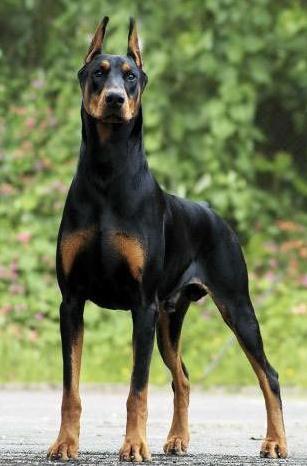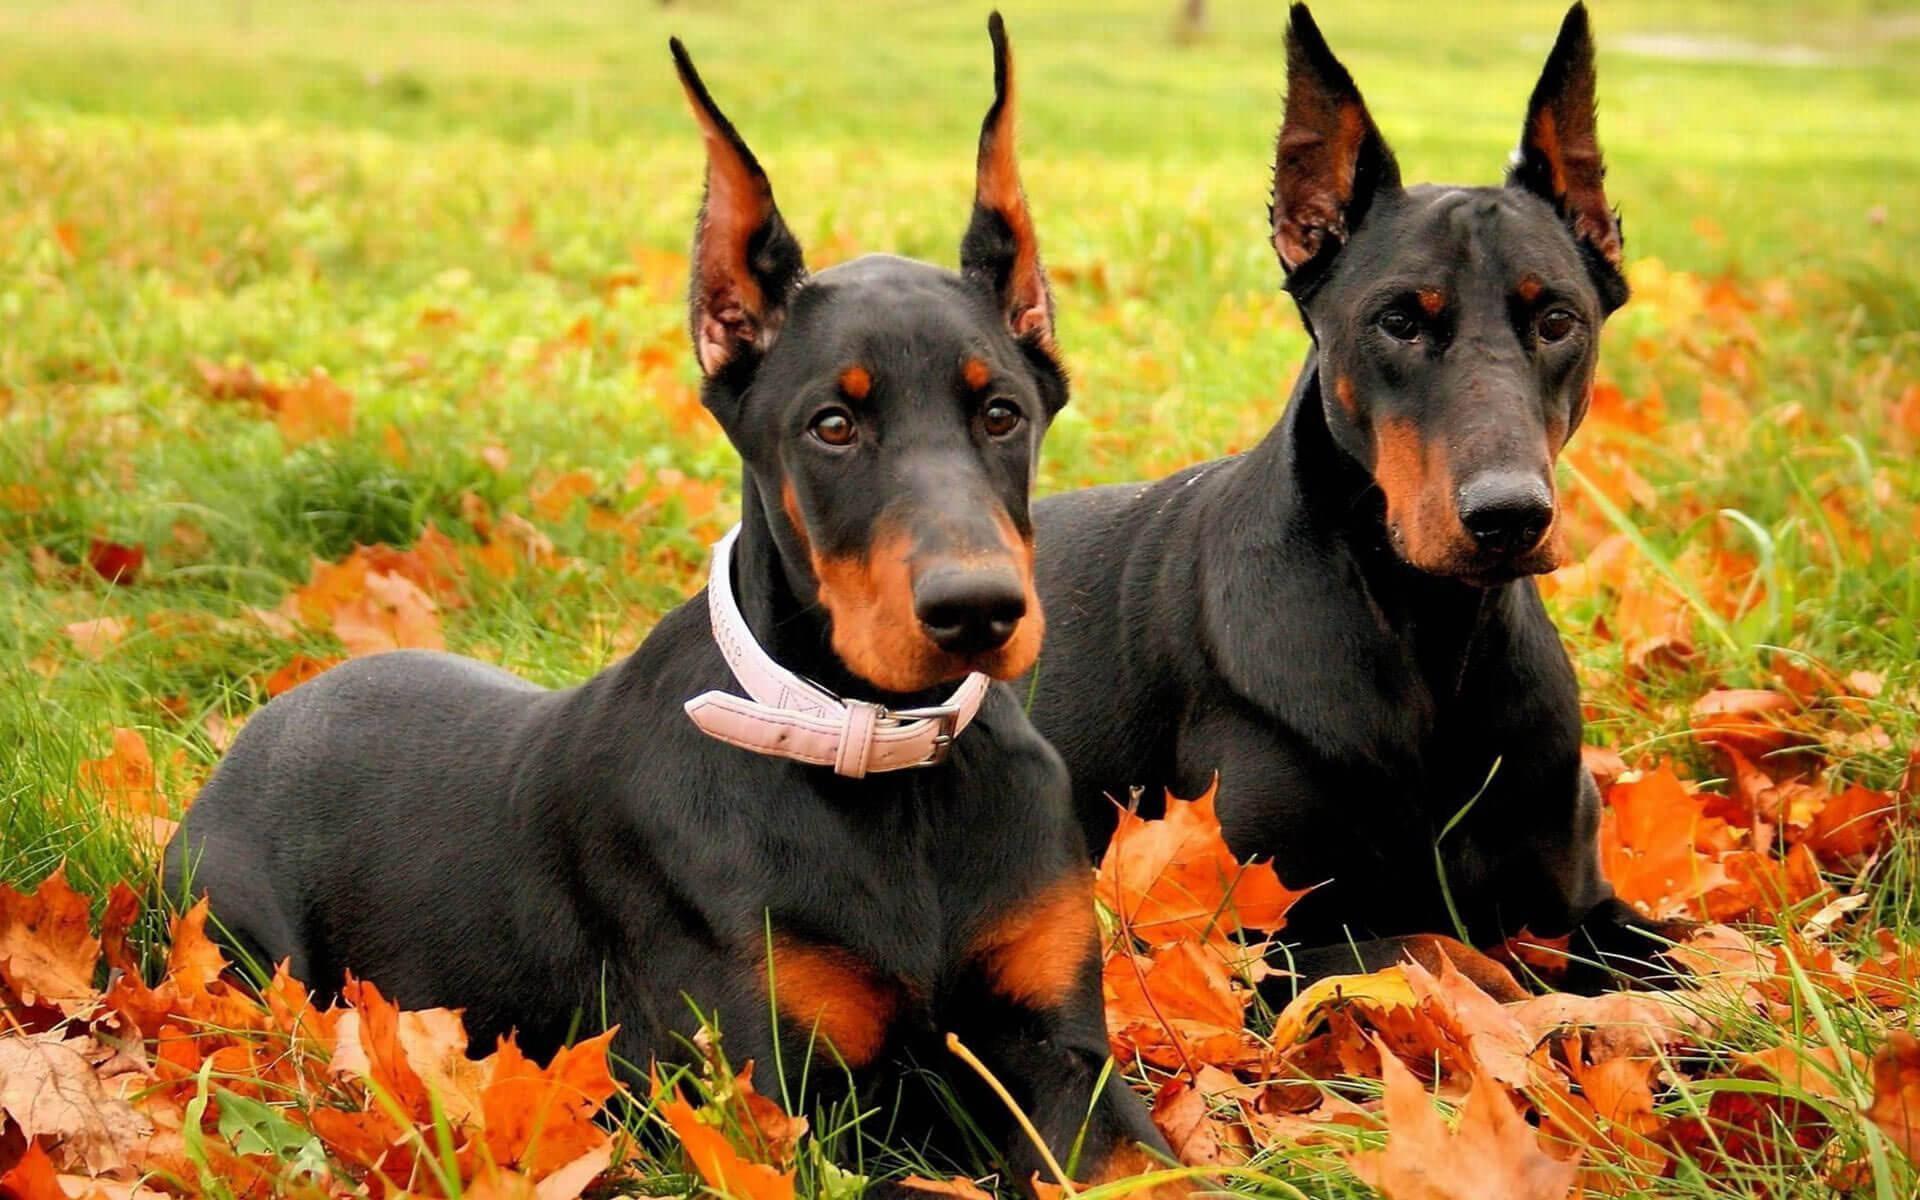The first image is the image on the left, the second image is the image on the right. Given the left and right images, does the statement "The left image contains exactly one dog." hold true? Answer yes or no. Yes. 